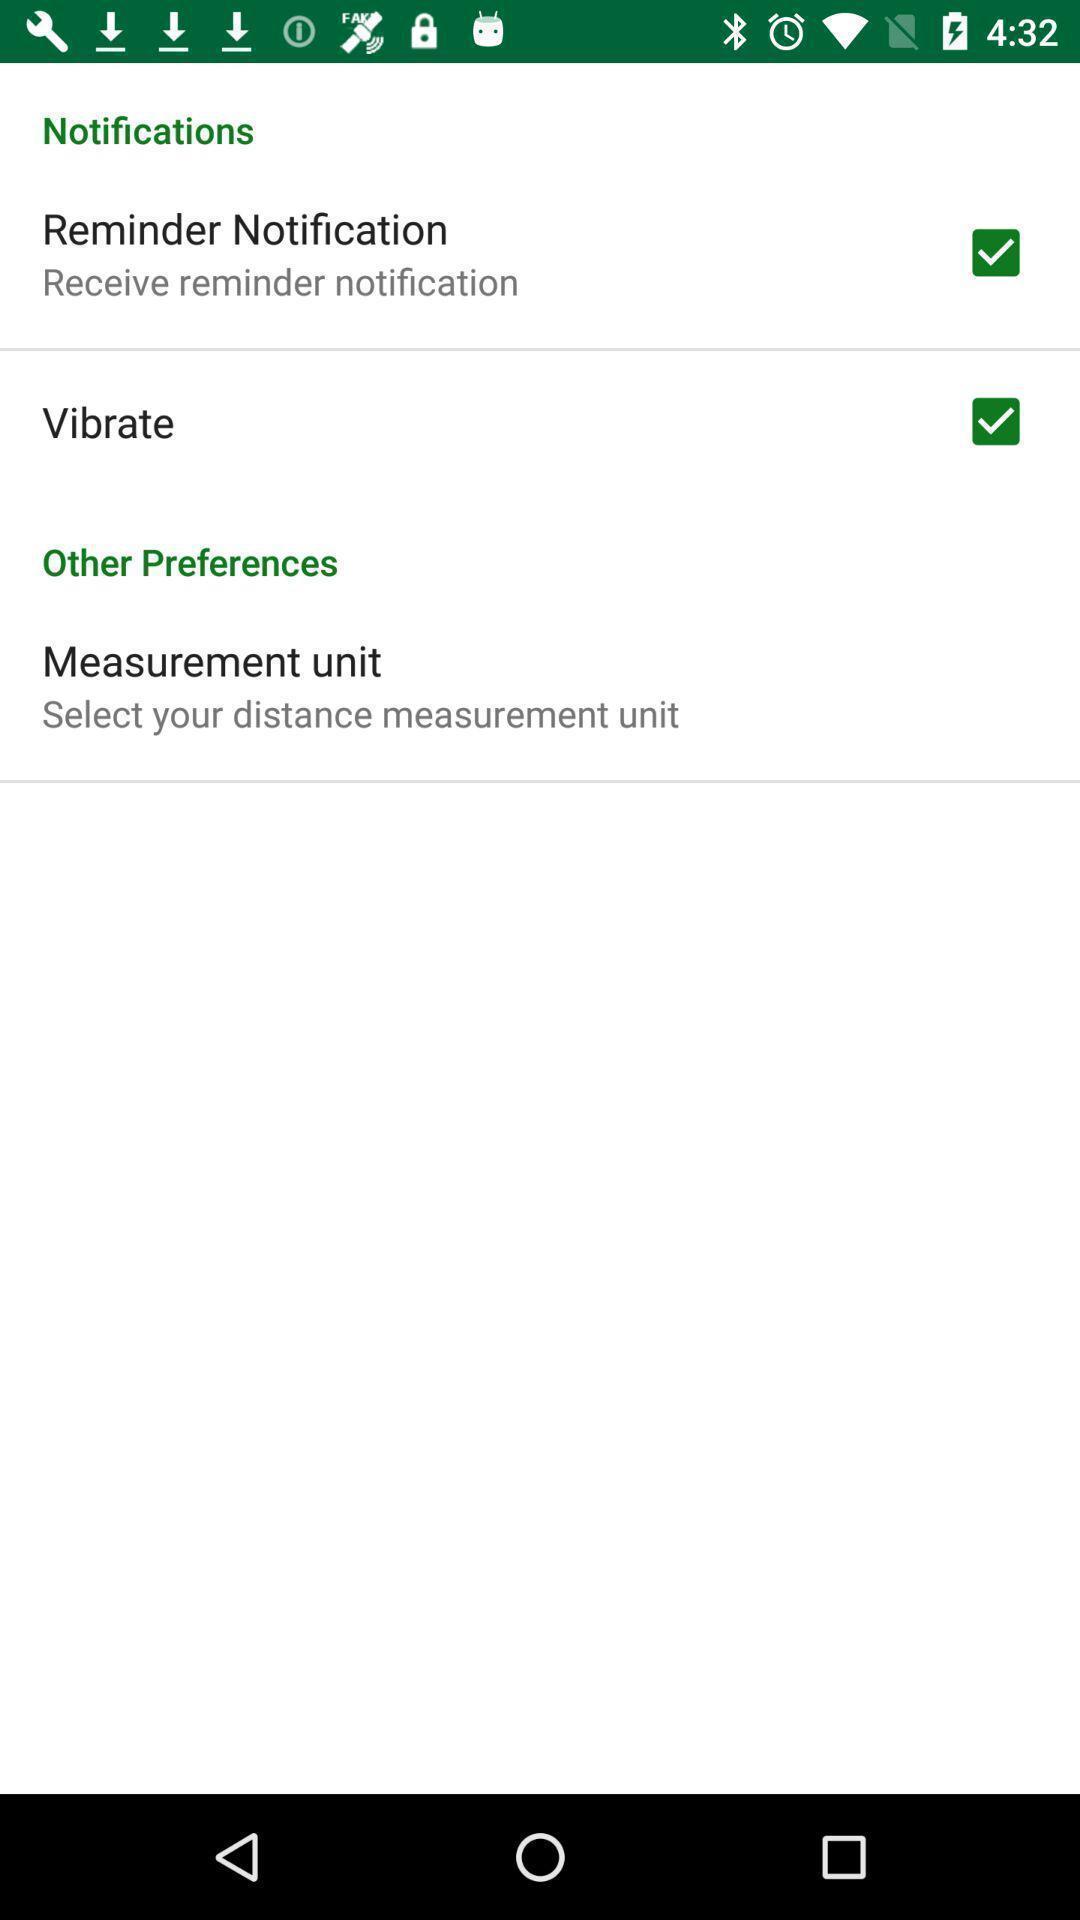Give me a summary of this screen capture. Screen displaying the list of options and check boxes. 